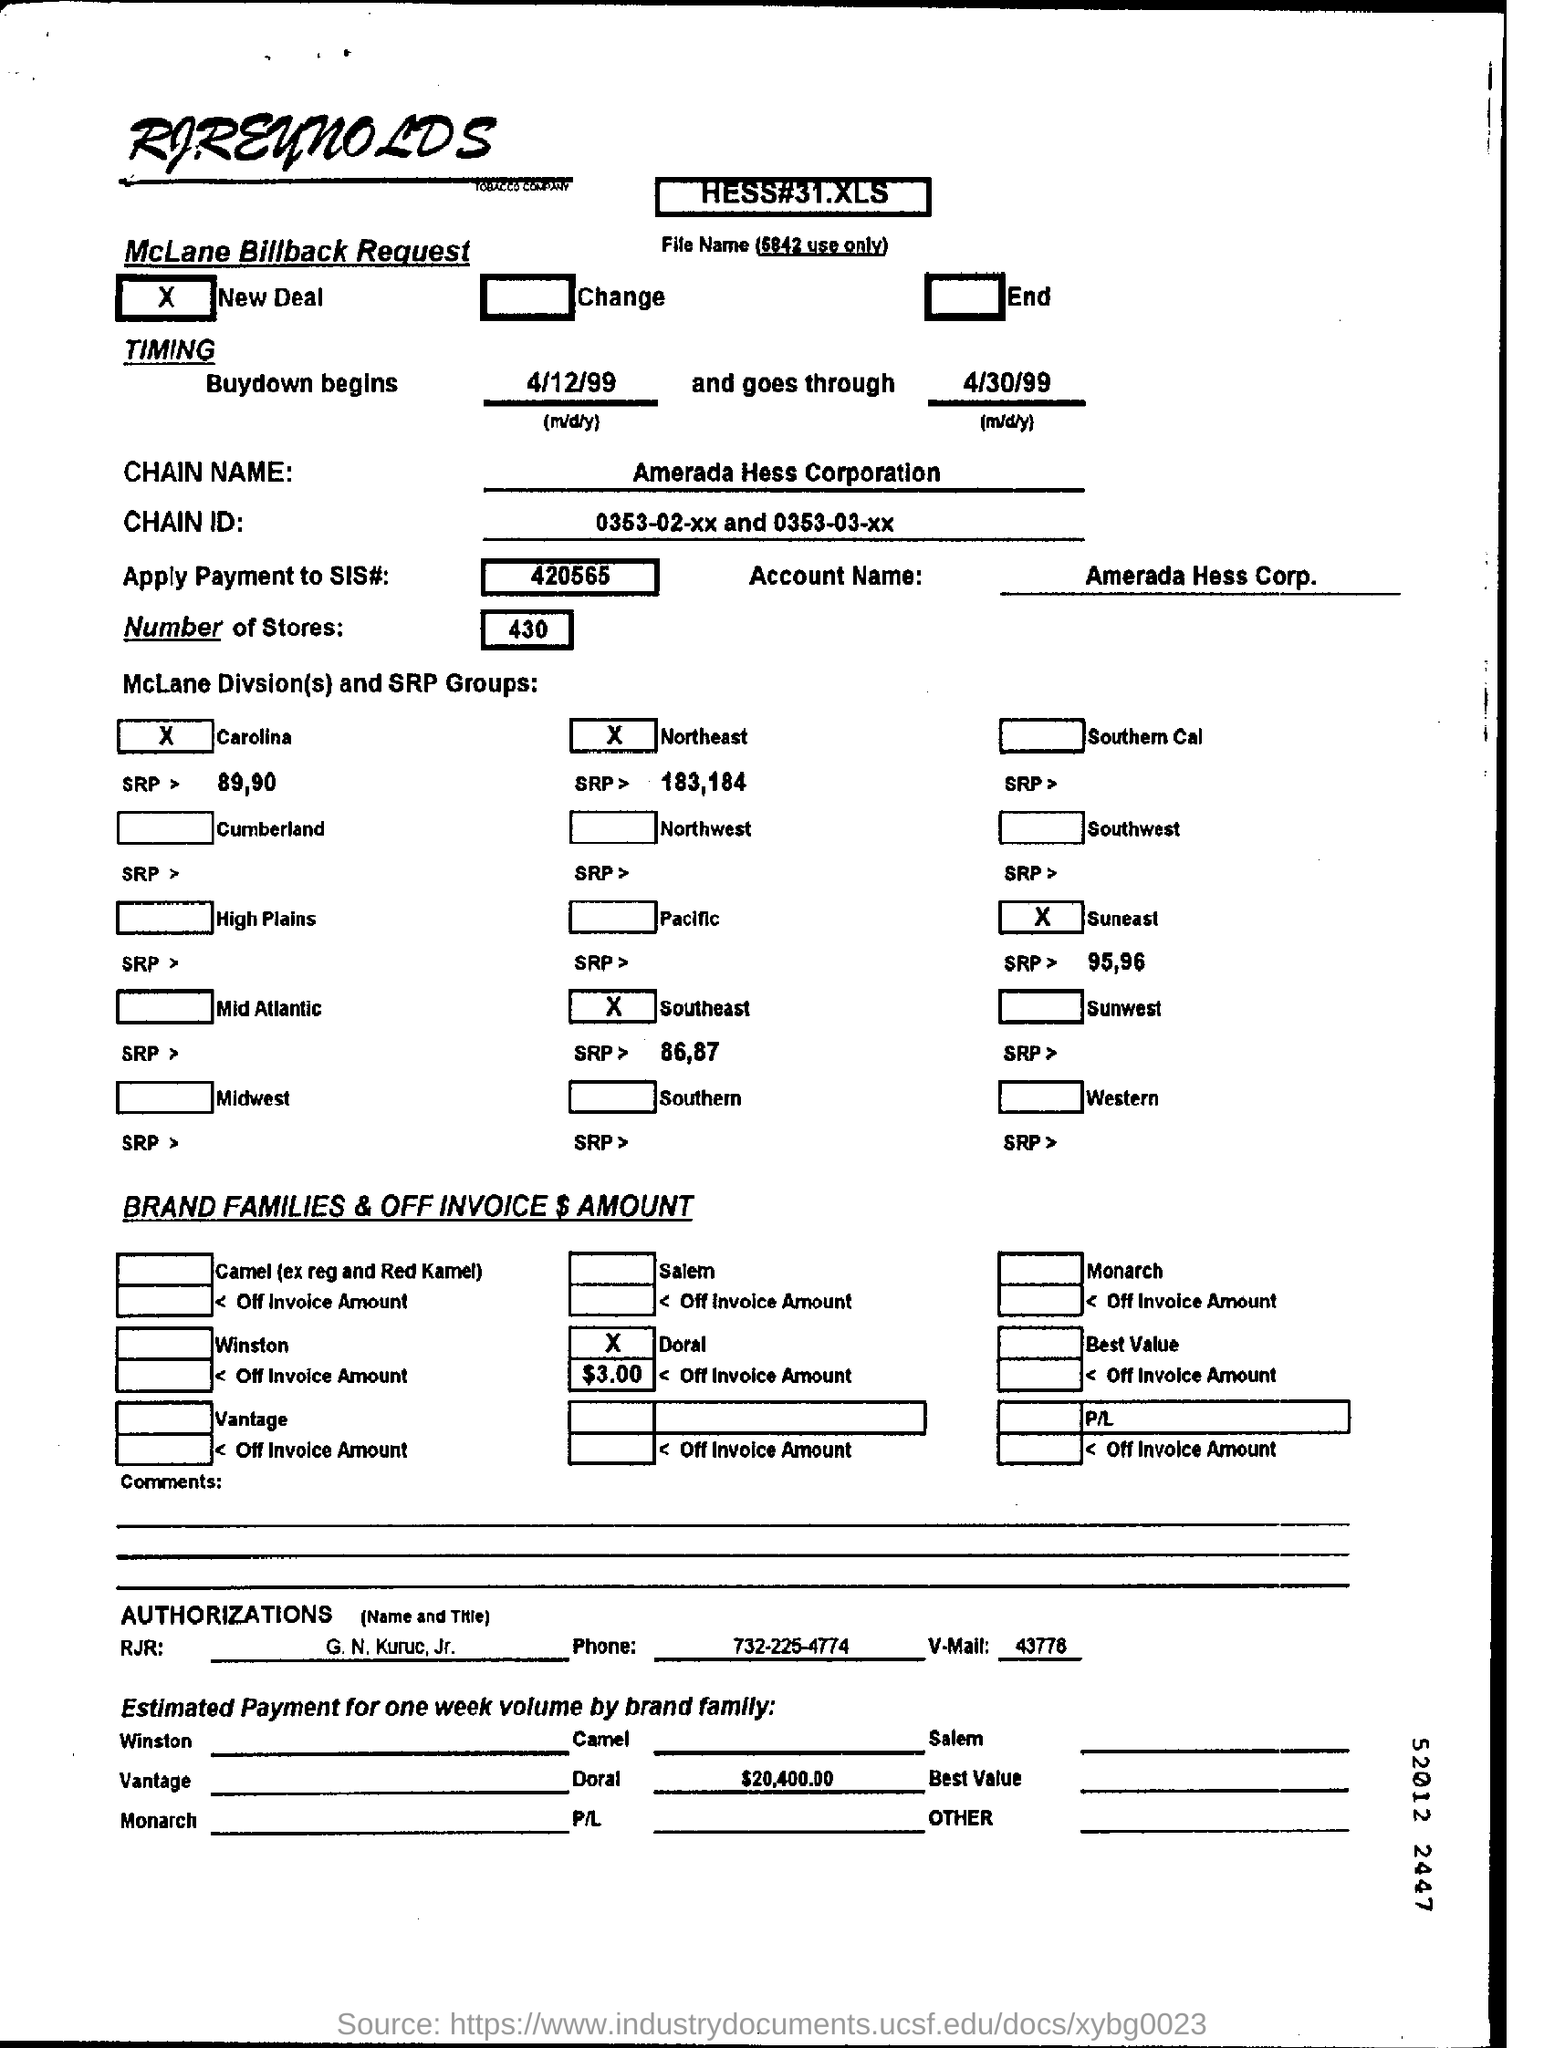Highlight a few significant elements in this photo. The estimated payment for Doral is approximately $20,400.00. The article states that there are 430 stores mentioned in the dataset. Amerada Hess Corporation" is a chain that is mentioned. The account name mentioned is "Amerada Hess Corp. I would like to know the process of applying payment to the specified payment number, which is 420565... 